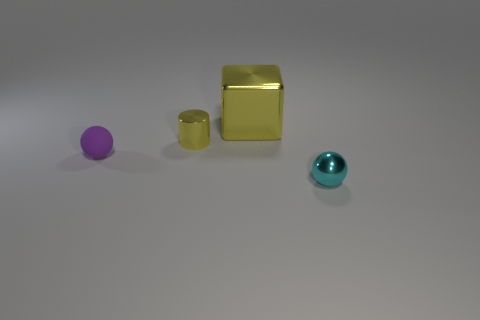What is the material of the yellow object right of the tiny object behind the purple ball?
Your answer should be very brief. Metal. Are the small thing that is to the right of the yellow cylinder and the block made of the same material?
Make the answer very short. Yes. What is the size of the yellow metal thing on the left side of the yellow block?
Ensure brevity in your answer.  Small. There is a tiny thing right of the tiny yellow metal cylinder; are there any small shiny cylinders left of it?
Give a very brief answer. Yes. Is the color of the tiny metallic cylinder that is behind the purple object the same as the big shiny thing that is behind the purple matte sphere?
Give a very brief answer. Yes. What is the color of the tiny rubber sphere?
Offer a very short reply. Purple. Is there any other thing that is the same color as the small rubber ball?
Keep it short and to the point. No. What is the color of the tiny object that is both on the right side of the small purple matte object and left of the tiny cyan sphere?
Ensure brevity in your answer.  Yellow. There is a cyan metallic object in front of the yellow metal block; is its size the same as the metallic block?
Your answer should be compact. No. Are there more metal things in front of the matte sphere than matte cubes?
Provide a succinct answer. Yes. 